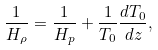<formula> <loc_0><loc_0><loc_500><loc_500>\frac { 1 } { H _ { \rho } } = \frac { 1 } { H _ { p } } + \frac { 1 } { T _ { 0 } } \frac { d T _ { 0 } } { d z } ,</formula> 